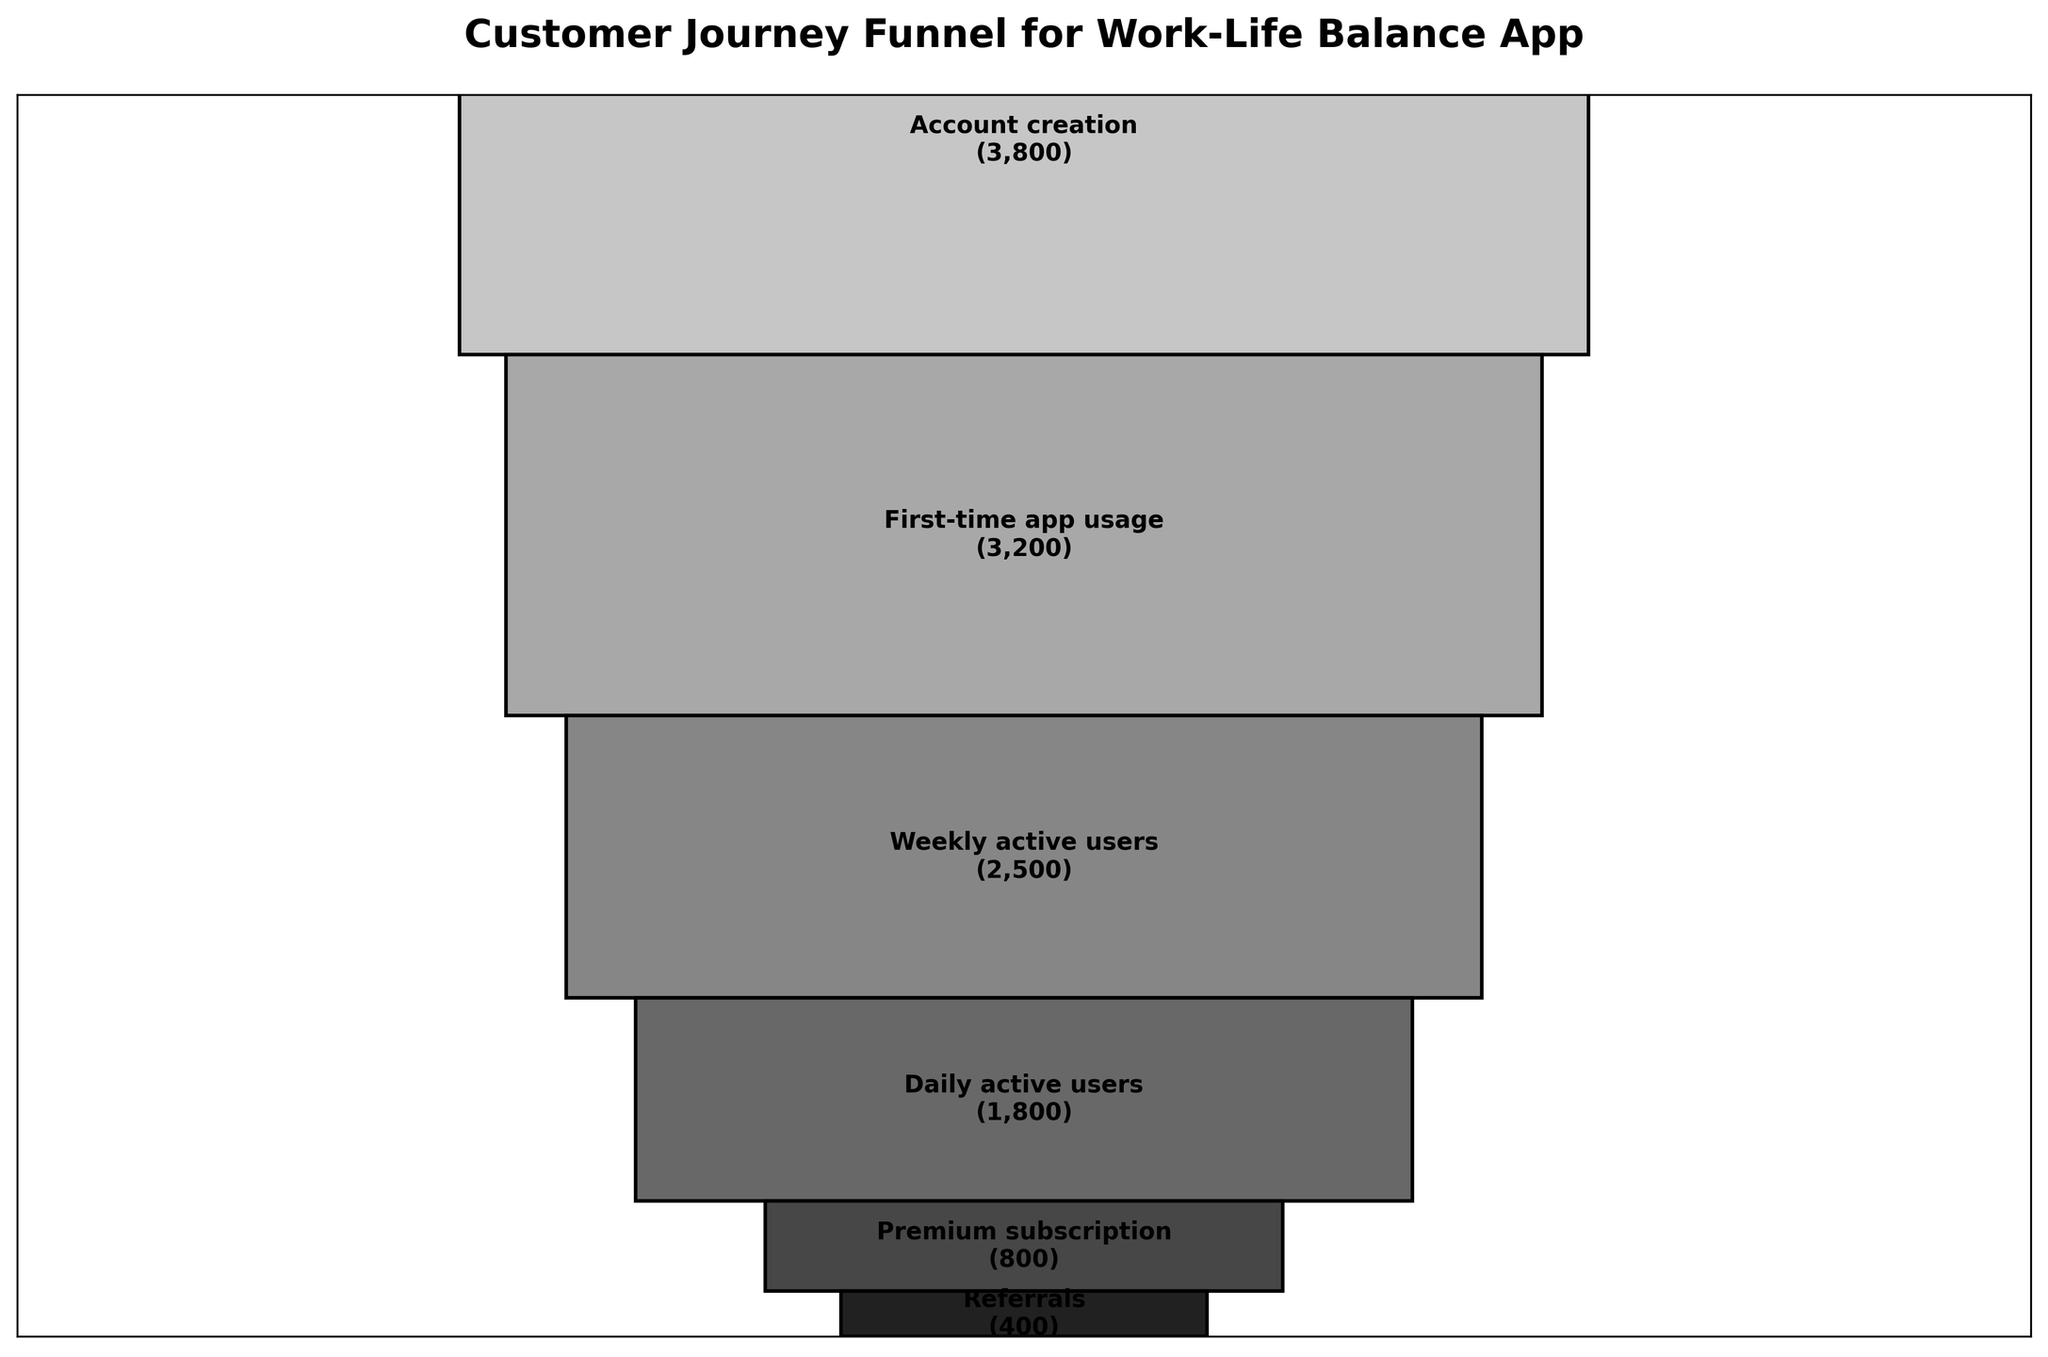How many users are there in the App store visits stage? The figure shows different stages of the customer journey with the corresponding number of users. Find the bar labeled "App store visits" and read the user count.
Answer: 7,500 What is the difference in users between the Awareness stage and the App downloads stage? Find the number of users in the "Awareness through work-life balance ads" stage (10,000) and the number in the "App downloads" stage (5,000). Subtract the App downloads number from the Awareness number: 10,000 - 5,000.
Answer: 5,000 Which stage has the largest drop in users from the previous stage? Examine each stage and compare the user drop from its preceding stage. The largest drop is found by subtracting numbers of users stage by stage.
Answer: Premium subscription What percentage of users who downloaded the app created an account? Find the number of users in the App downloads stage (5,000) and the Account creation stage (3,800). Calculate the percentage: (3,800 / 5,000) * 100.
Answer: 76% Which is higher, the number of Daily active users or First-time app usage? Compare the numbers for the stages labeled "Daily active users" (1,800) and "First-time app usage" (3,200).
Answer: First-time app usage What is the total number of users from the Weekly active users stage to the end of the funnel? Sum the number of users from the Weekly active users (2,500), Daily active users (1,800), Premium subscription (800), and Referrals (400): 2,500 + 1,800 + 800 + 400.
Answer: 5,500 At which stage do fewer than half of the total initial users remain? Compare each stage's user count to half of the initial users in the Awareness stage (10,000 / 2 = 5,000). Identify the stage where the user count drops below 5,000.
Answer: App downloads How many users progressed from the Weekly active users stage to becoming Daily active users? Find the number of users in the Weekly active users stage (2,500) and the Daily active users stage (1,800). Subtract the Daily active users count from the Weekly active users: 2,500 - 1,800.
Answer: 700 What is the retention rate of users from the App downloads stage to the Premium subscription stage? Find the number of users in the App downloads stage (5,000) and the Premium subscription stage (800). Calculate the retention rate: (800 / 5,000) * 100.
Answer: 16% What stage directly precedes the Referrals stage and how many users are there in that stage? Identify the stage that comes directly before "Referrals" which is "Premium subscription". Look at the user count for the Premium subscription stage.
Answer: Premium subscription, 800 